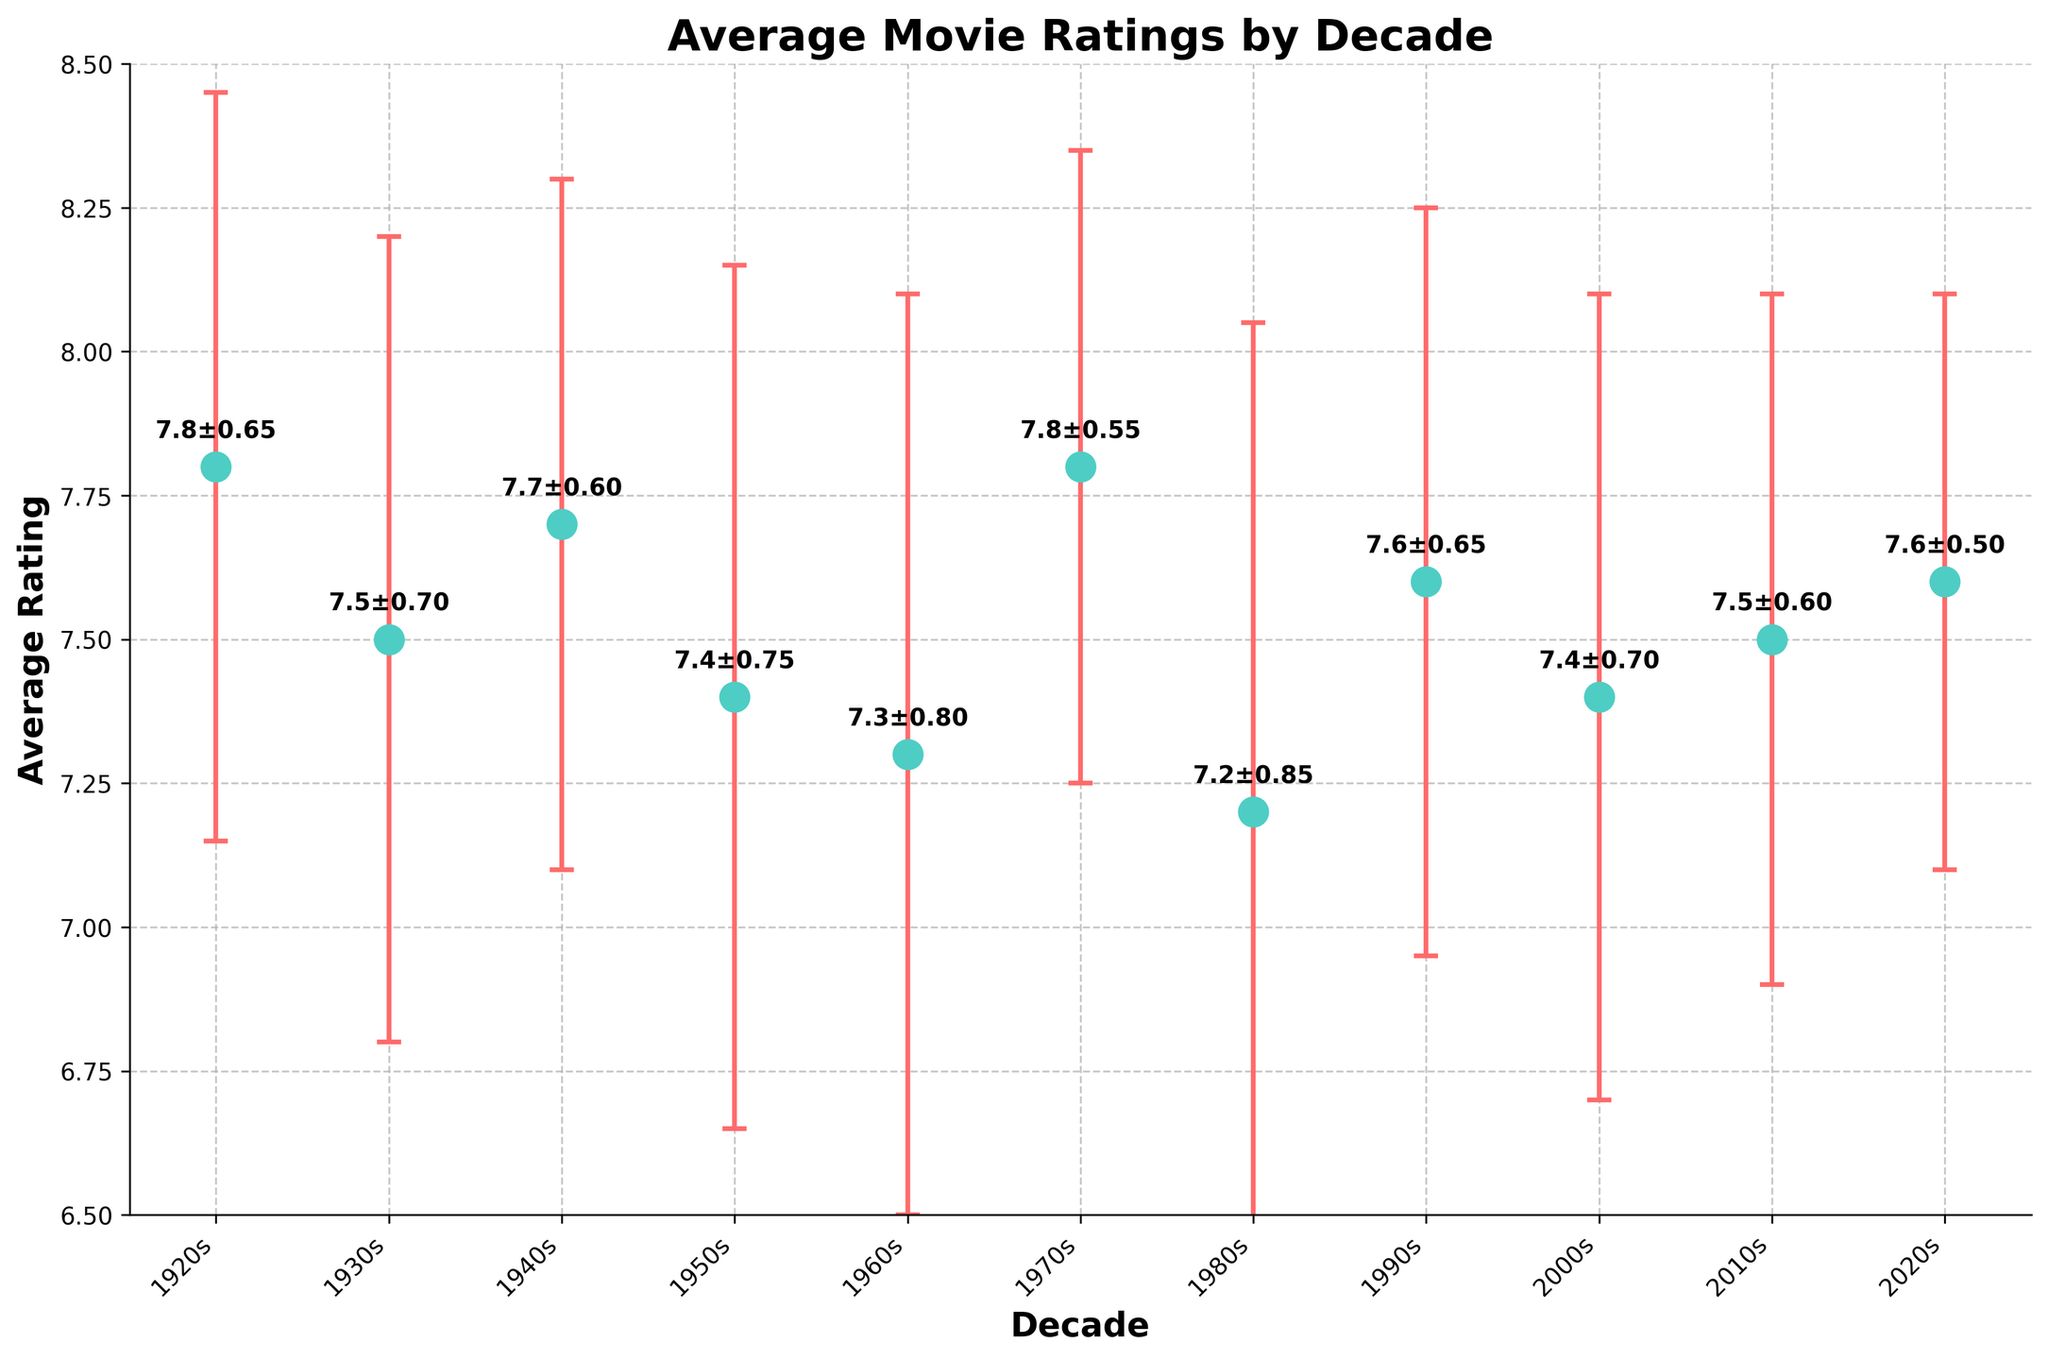What is the decade with the highest average movie rating? The average ratings for each decade are plotted, and the highest of these is 7.8, which occurs in both the 1920s and the 1970s.
Answer: 1920s and 1970s What is the average rating for movies in the 1950s? The dot plot shows the average rating for each decade. For the 1950s, it is 7.4.
Answer: 7.4 Which decade has the largest standard deviation? The standard deviations are indicated by the error bars. The 1980s has the largest error bar, with a standard deviation of 0.85.
Answer: 1980s Is the average rating for the 1980s higher or lower than the 1930s? The average rating is 7.2 for the 1980s and 7.5 for the 1930s, so it is lower in the 1980s.
Answer: Lower What is the difference in average movie ratings between the 1960s and the 2000s? From the dot plot, the average rating in the 1960s is 7.3, and for the 2000s, it is 7.4. The difference is 7.4 - 7.3 = 0.1.
Answer: 0.1 Which decade has the smallest average rating, and is the standard deviation large or small for that decade? The 1980s has the smallest average rating at 7.2, and its standard deviation is relatively large at 0.85.
Answer: 1980s; large What is the trend in average movie ratings from the 1960s to the 1990s? The average ratings decrease from 7.3 in the 1960s to 7.2 in the 1980s and then increase to 7.6 in the 1990s. So, the trend is first a decrease and then an increase.
Answer: Decrease, then increase Are the average ratings for the 1920s and the 2010s statistically distinct from each other, considering their standard deviations? The average ratings are 7.8 (1920s) and 7.5 (2010s), with standard deviations of 0.65 and 0.60 respectively. The overlap between error bars suggests that they are not statistically distinct.
Answer: Not distinct How does the average rating in the 2020s compare to the overall trend in movie ratings? The average rating in the 2020s is 7.6, which is higher than the preceding decades (2000s and 2010s) and represents an upward trend.
Answer: Higher and upward trend What can be inferred about the stability of movie ratings over the decades? By observing the standard deviations (error bars), we see that certain decades, like the 1970s, have lower variability (0.55) compared to others, like the 1980s (0.85). This indicates more stability in some decades compared to others.
Answer: Varies by decade 